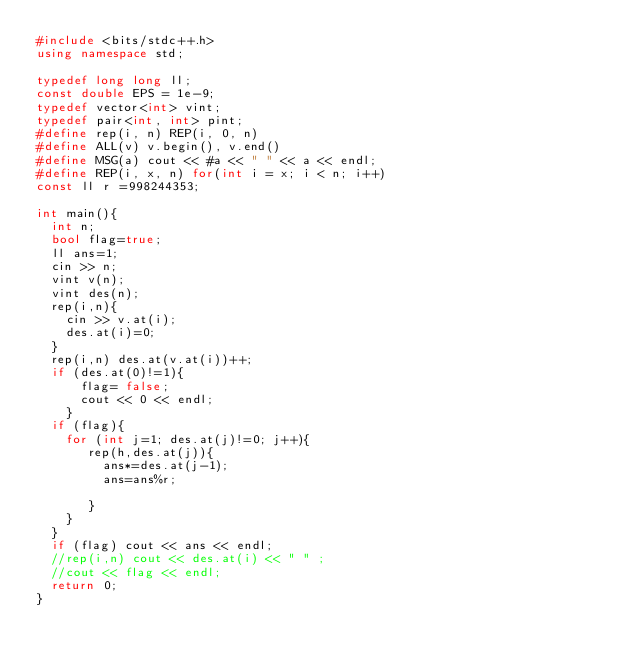Convert code to text. <code><loc_0><loc_0><loc_500><loc_500><_C++_>#include <bits/stdc++.h>
using namespace std;

typedef long long ll;
const double EPS = 1e-9;
typedef vector<int> vint;
typedef pair<int, int> pint;
#define rep(i, n) REP(i, 0, n)
#define ALL(v) v.begin(), v.end()
#define MSG(a) cout << #a << " " << a << endl;
#define REP(i, x, n) for(int i = x; i < n; i++)
const ll r =998244353;

int main(){
  int n;
  bool flag=true;
  ll ans=1;
  cin >> n;
  vint v(n);
  vint des(n);
  rep(i,n){
    cin >> v.at(i);
    des.at(i)=0;
  }
  rep(i,n) des.at(v.at(i))++;
  if (des.at(0)!=1){
      flag= false;
      cout << 0 << endl;
    }
  if (flag){
    for (int j=1; des.at(j)!=0; j++){
       rep(h,des.at(j)){
         ans*=des.at(j-1);
         ans=ans%r;
         
       }
    }
  }
  if (flag) cout << ans << endl;
  //rep(i,n) cout << des.at(i) << " " ;
  //cout << flag << endl;
  return 0;
}
</code> 